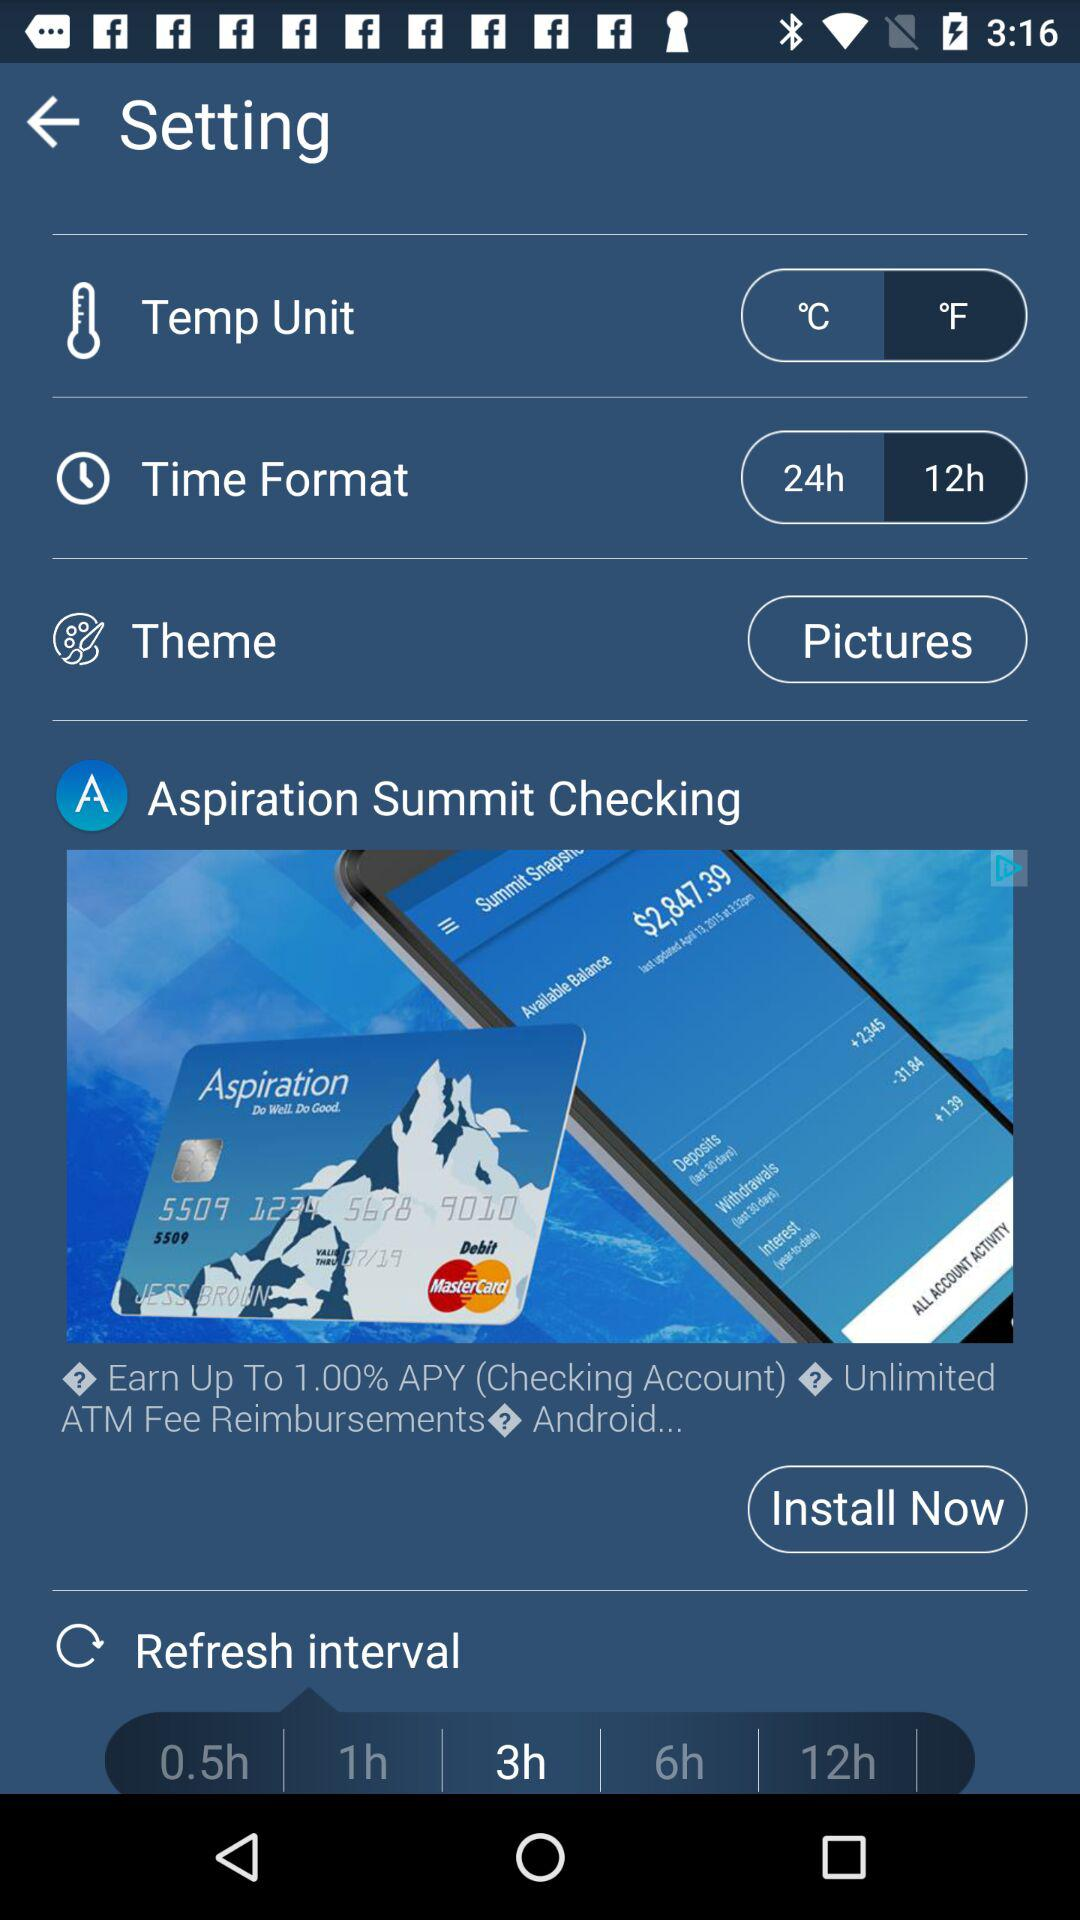Which temp unit is selected? The selected temp unit is °F. 